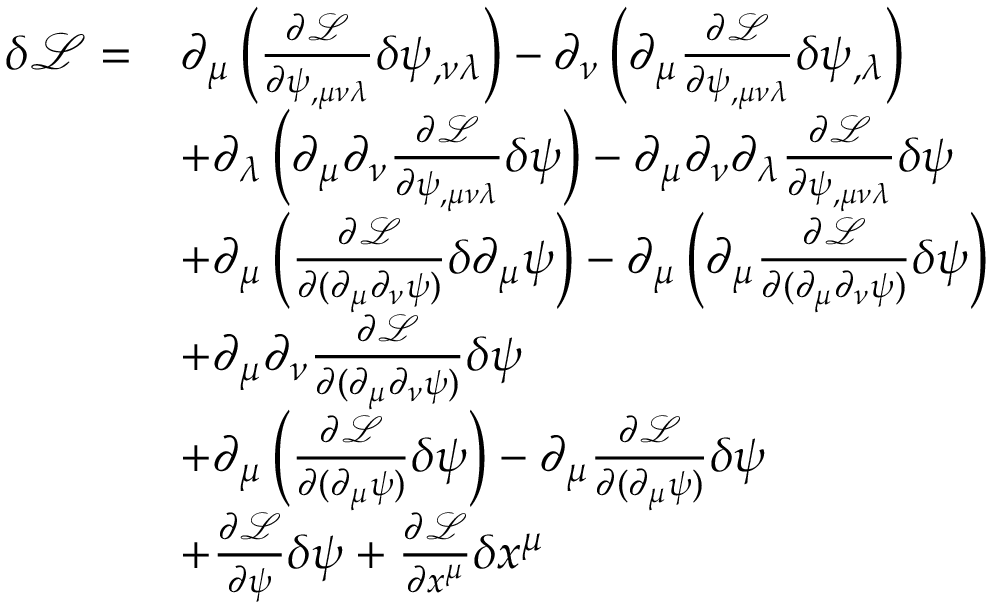Convert formula to latex. <formula><loc_0><loc_0><loc_500><loc_500>\begin{array} { r l } { \delta \mathcal { L } = } & { \partial _ { \mu } \left ( \frac { \partial \mathcal { L } } { \partial \psi _ { , \mu \nu \lambda } } \delta \psi _ { , \nu \lambda } \right ) - \partial _ { \nu } \left ( \partial _ { \mu } \frac { \partial \mathcal { L } } { \partial \psi _ { , \mu \nu \lambda } } \delta \psi _ { , \lambda } \right ) } \\ & { + \partial _ { \lambda } \left ( \partial _ { \mu } \partial _ { \nu } \frac { \partial \mathcal { L } } { \partial \psi _ { , \mu \nu \lambda } } \delta \psi \right ) - \partial _ { \mu } \partial _ { \nu } \partial _ { \lambda } \frac { \partial \mathcal { L } } { \partial \psi _ { , \mu \nu \lambda } } \delta \psi } \\ & { + \partial _ { \mu } \left ( \frac { \partial \mathcal { L } } { \partial ( \partial _ { \mu } \partial _ { \nu } \psi ) } \delta \partial _ { \mu } \psi \right ) - \partial _ { \mu } \left ( \partial _ { \mu } \frac { \partial \mathcal { L } } { \partial ( \partial _ { \mu } \partial _ { \nu } \psi ) } \delta \psi \right ) } \\ & { + \partial _ { \mu } \partial _ { \nu } \frac { \partial \mathcal { L } } { \partial ( \partial _ { \mu } \partial _ { \nu } \psi ) } \delta \psi } \\ & { + \partial _ { \mu } \left ( \frac { \partial \mathcal { L } } { \partial ( \partial _ { \mu } \psi ) } \delta \psi \right ) - \partial _ { \mu } \frac { \partial \mathcal { L } } { \partial ( \partial _ { \mu } \psi ) } \delta \psi } \\ & { + \frac { \partial \mathcal { L } } { \partial \psi } \delta \psi + \frac { \partial \mathcal { L } } { \partial x ^ { \mu } } \delta x ^ { \mu } } \end{array}</formula> 